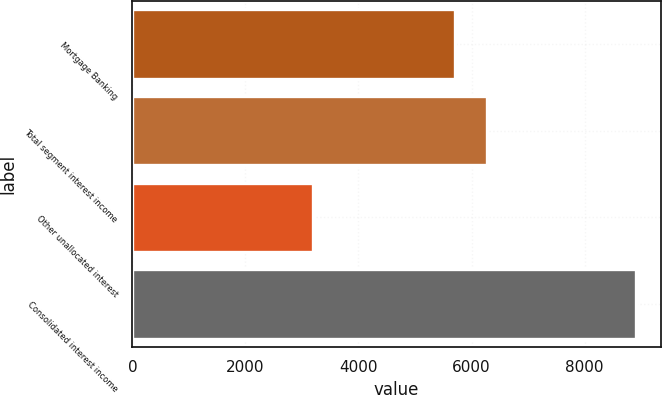Convert chart to OTSL. <chart><loc_0><loc_0><loc_500><loc_500><bar_chart><fcel>Mortgage Banking<fcel>Total segment interest income<fcel>Other unallocated interest<fcel>Consolidated interest income<nl><fcel>5702<fcel>6272.2<fcel>3202<fcel>8904<nl></chart> 